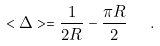<formula> <loc_0><loc_0><loc_500><loc_500>< \Delta > = \frac { 1 } { 2 R } - \frac { \pi R } { 2 } \ \ .</formula> 